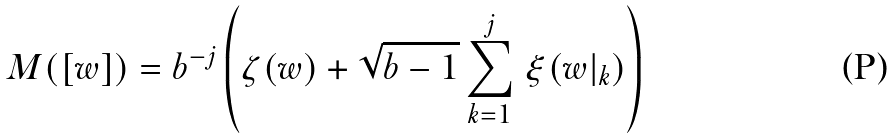<formula> <loc_0><loc_0><loc_500><loc_500>M ( [ w ] ) = b ^ { - j } \left ( \zeta ( w ) + \sqrt { b - 1 } \sum _ { k = 1 } ^ { j } \, \xi ( w | _ { k } ) \right )</formula> 